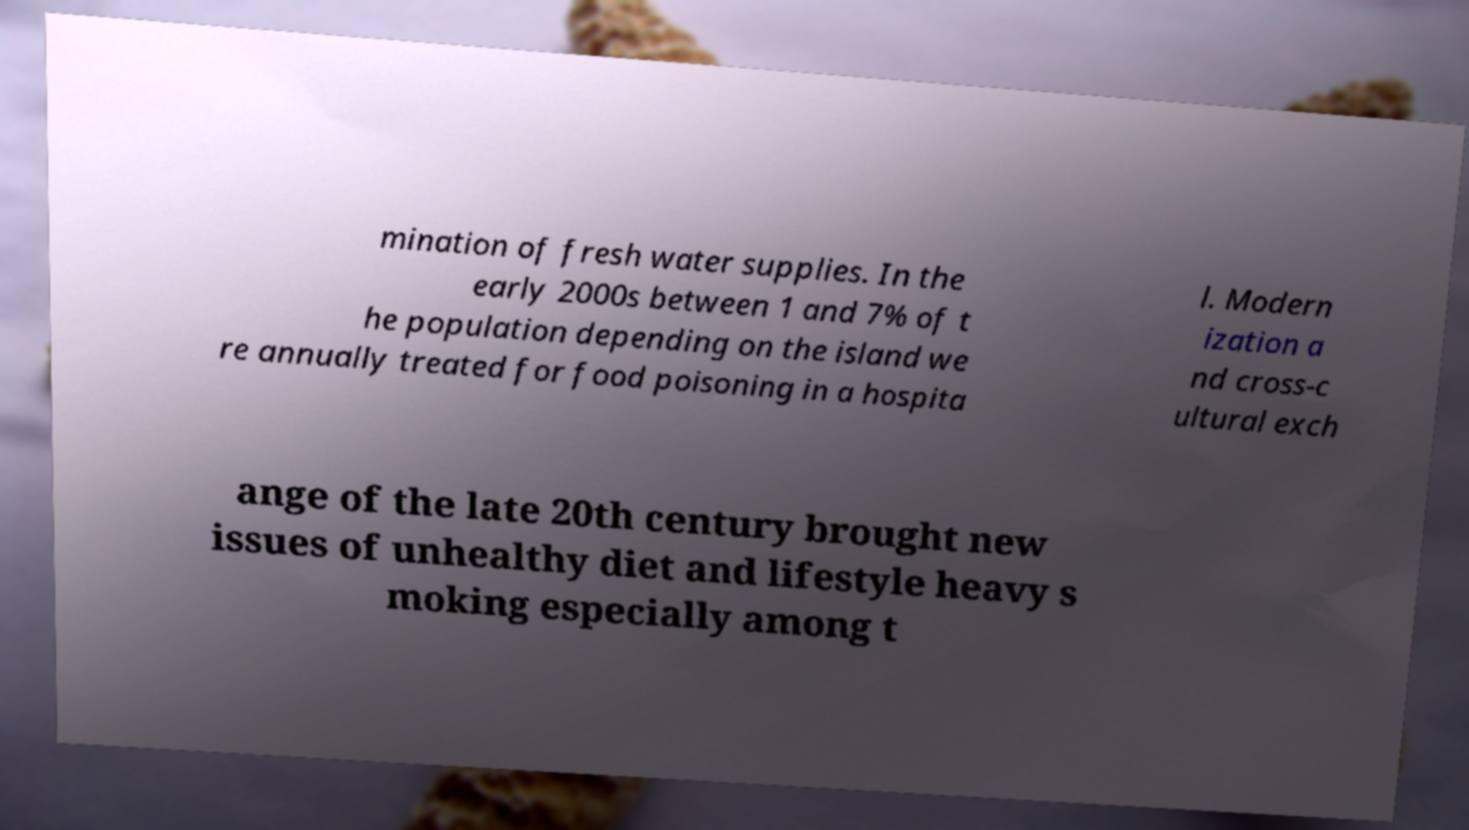Can you accurately transcribe the text from the provided image for me? mination of fresh water supplies. In the early 2000s between 1 and 7% of t he population depending on the island we re annually treated for food poisoning in a hospita l. Modern ization a nd cross-c ultural exch ange of the late 20th century brought new issues of unhealthy diet and lifestyle heavy s moking especially among t 